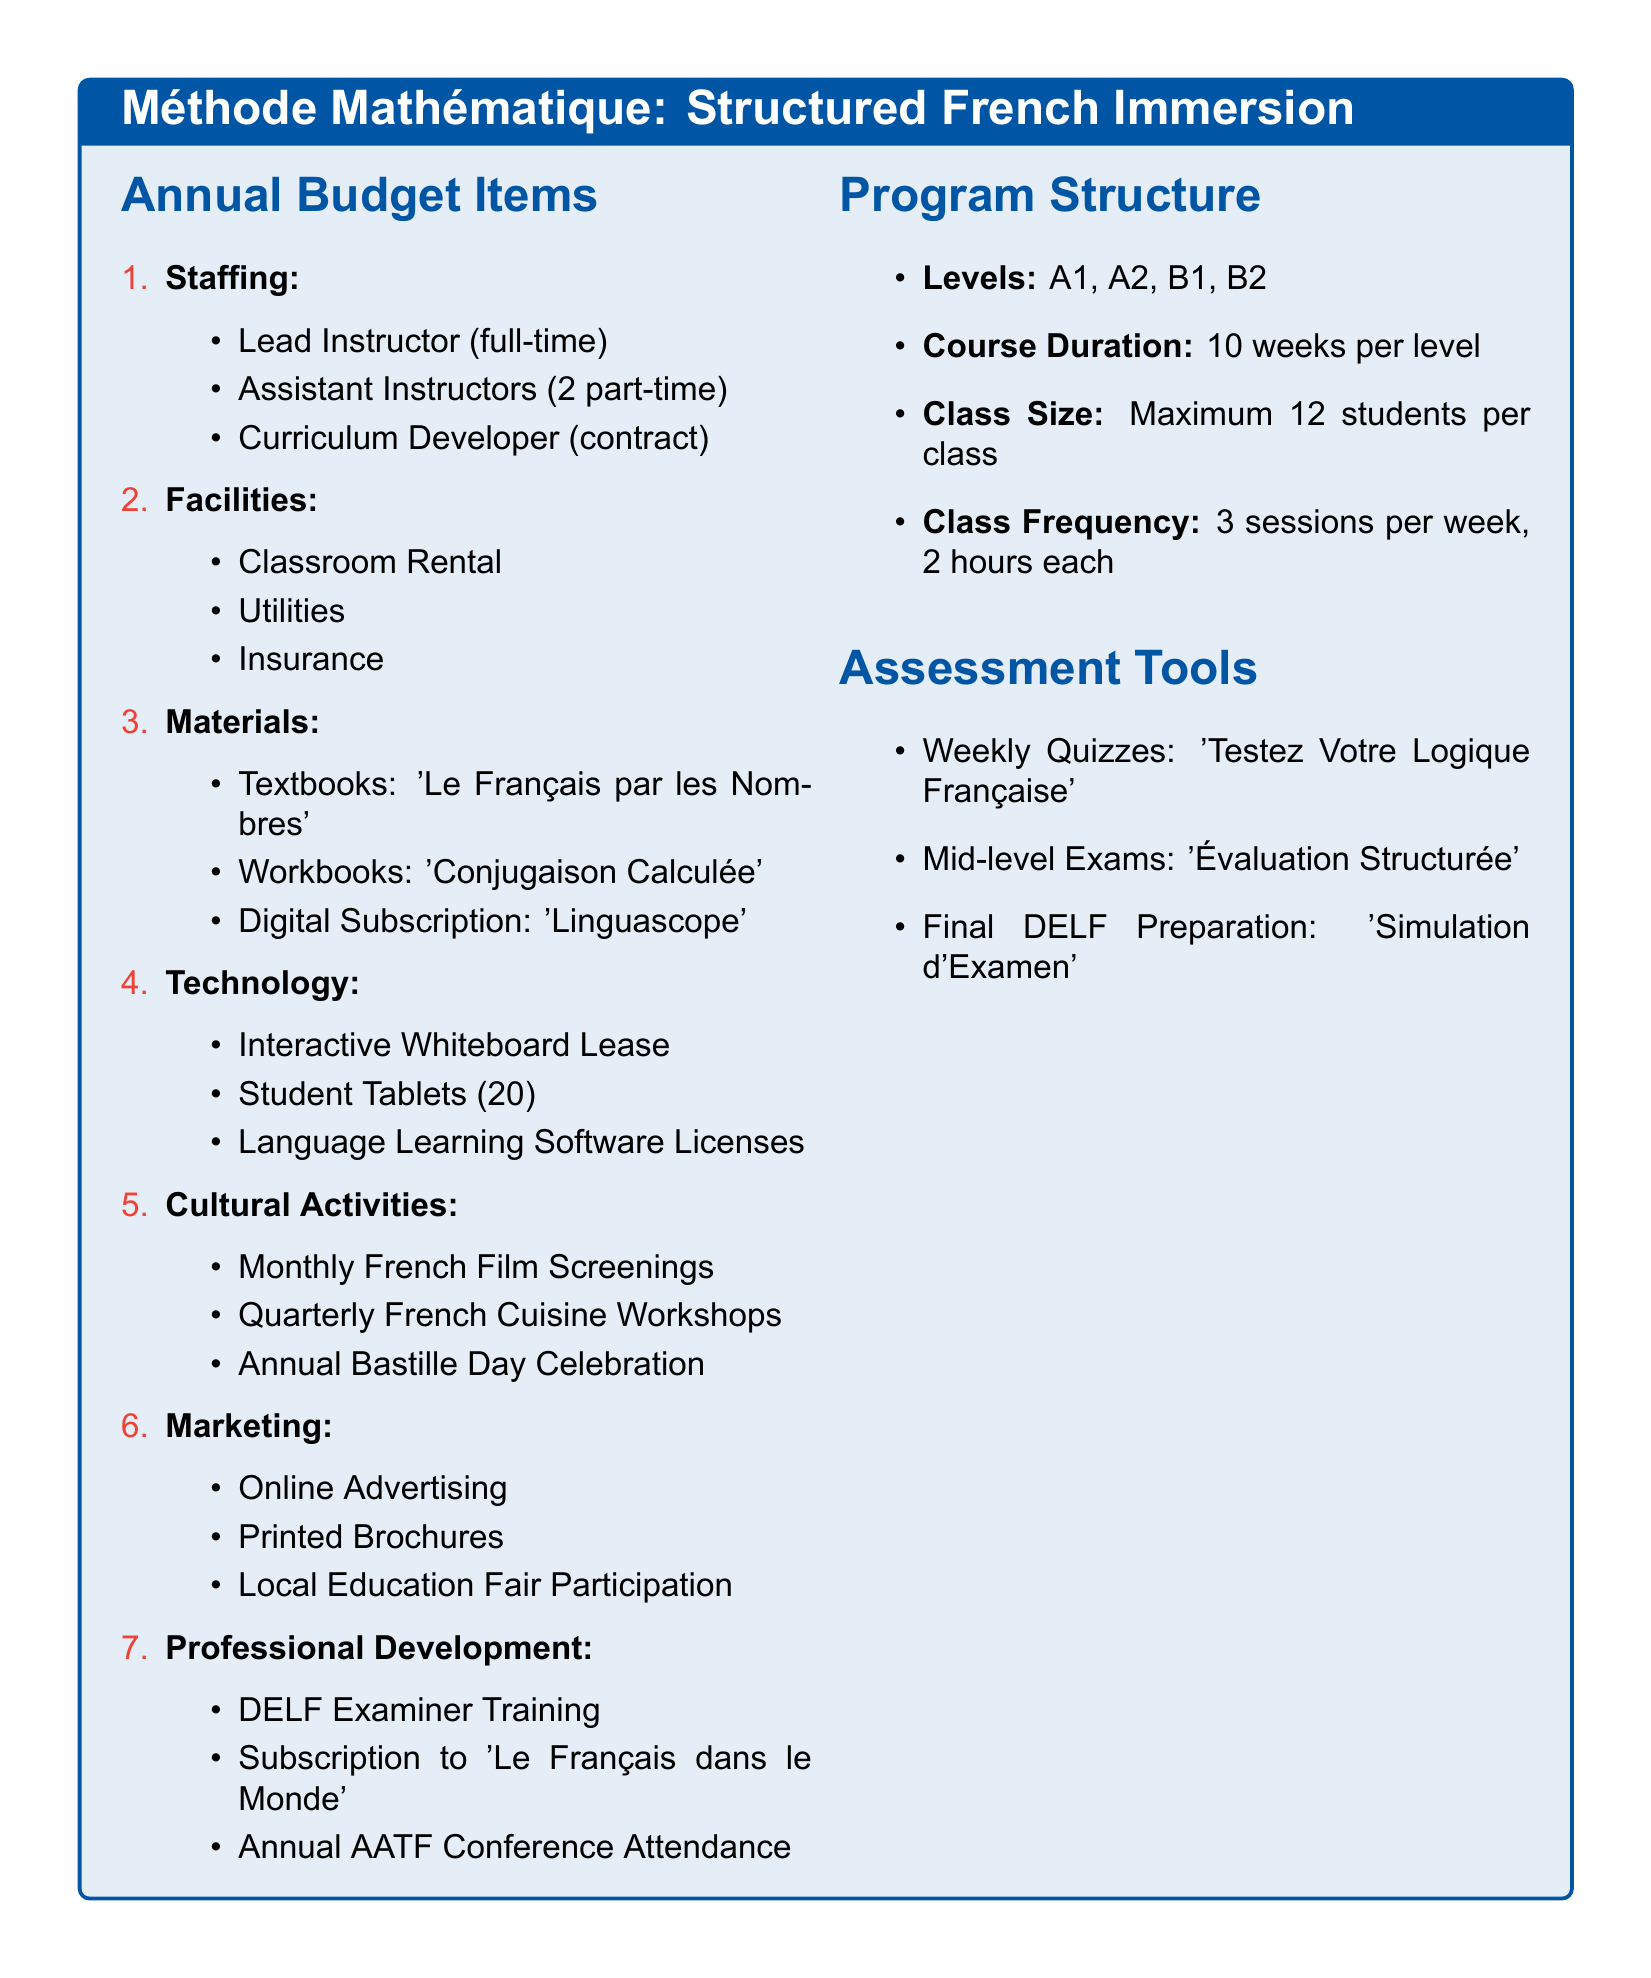what is the course duration per level? The document states that each level has a course duration of 10 weeks.
Answer: 10 weeks how many assistant instructors are there? The document mentions 2 part-time assistant instructors as part of staffing.
Answer: 2 part-time what is included in the cultural activities? The document lists monthly French film screenings, quarterly French cuisine workshops, and an annual Bastille Day celebration as part of cultural activities.
Answer: Monthly French film screenings, quarterly French cuisine workshops, annual Bastille Day celebration how many students are in a class? The document indicates the class size is a maximum of 12 students per class.
Answer: 12 students what is the main textbook used? The document lists 'Le Français par les Nombres' as the main textbook in materials.
Answer: 'Le Français par les Nombres' what are the assessment tools used? The document mentions weekly quizzes, mid-level exams, and final DELF preparation as the assessment tools.
Answer: Weekly quizzes, mid-level exams, final DELF preparation how often are classes held? The document specifies that classes are held 3 sessions per week.
Answer: 3 sessions per week what type of training is offered for professional development? The document lists DELF examiner training as part of professional development.
Answer: DELF examiner training 